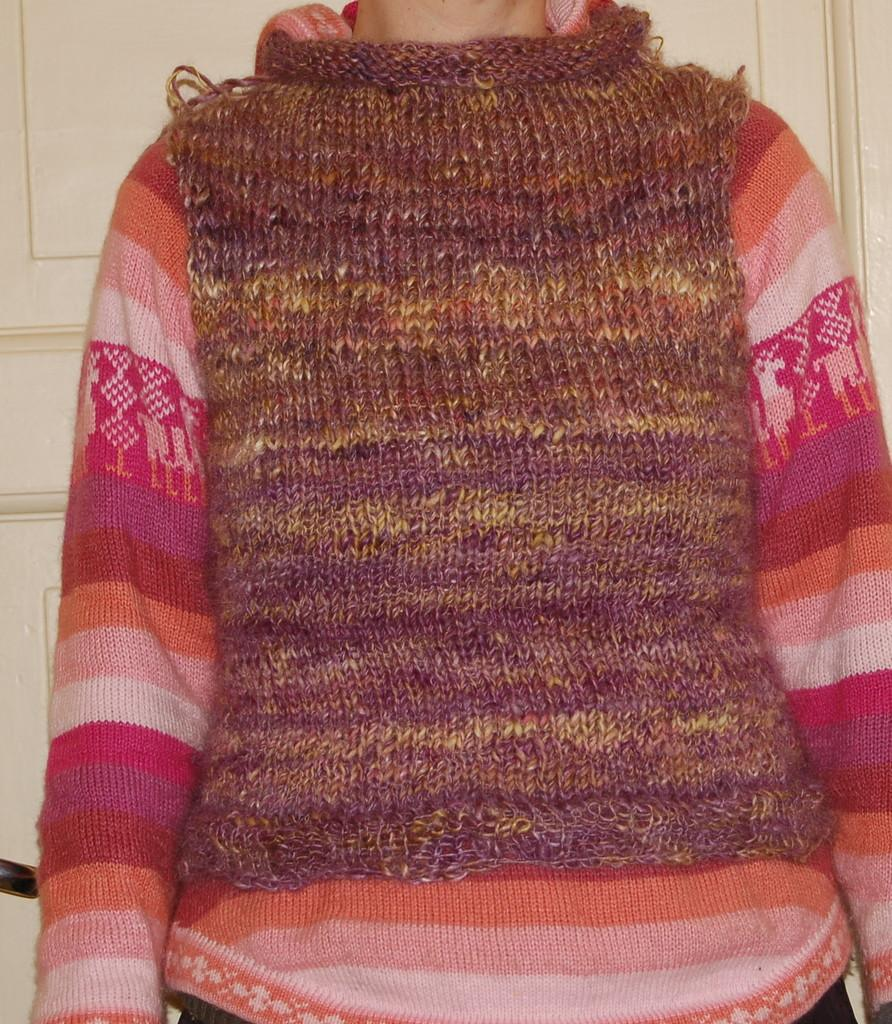Who or what is in the image? There is a person in the image. What is the person wearing? The person is wearing a brown color jacket. What can be seen in the background of the image? There is a door in the background of the image. How many forks are visible in the image? There are no forks present in the image. What type of neck is the person wearing in the image? The person is wearing a jacket, not a neck, in the image. 